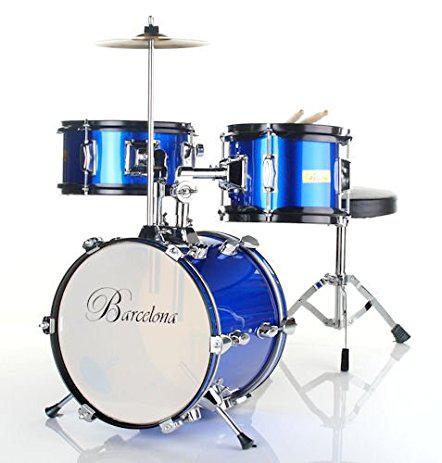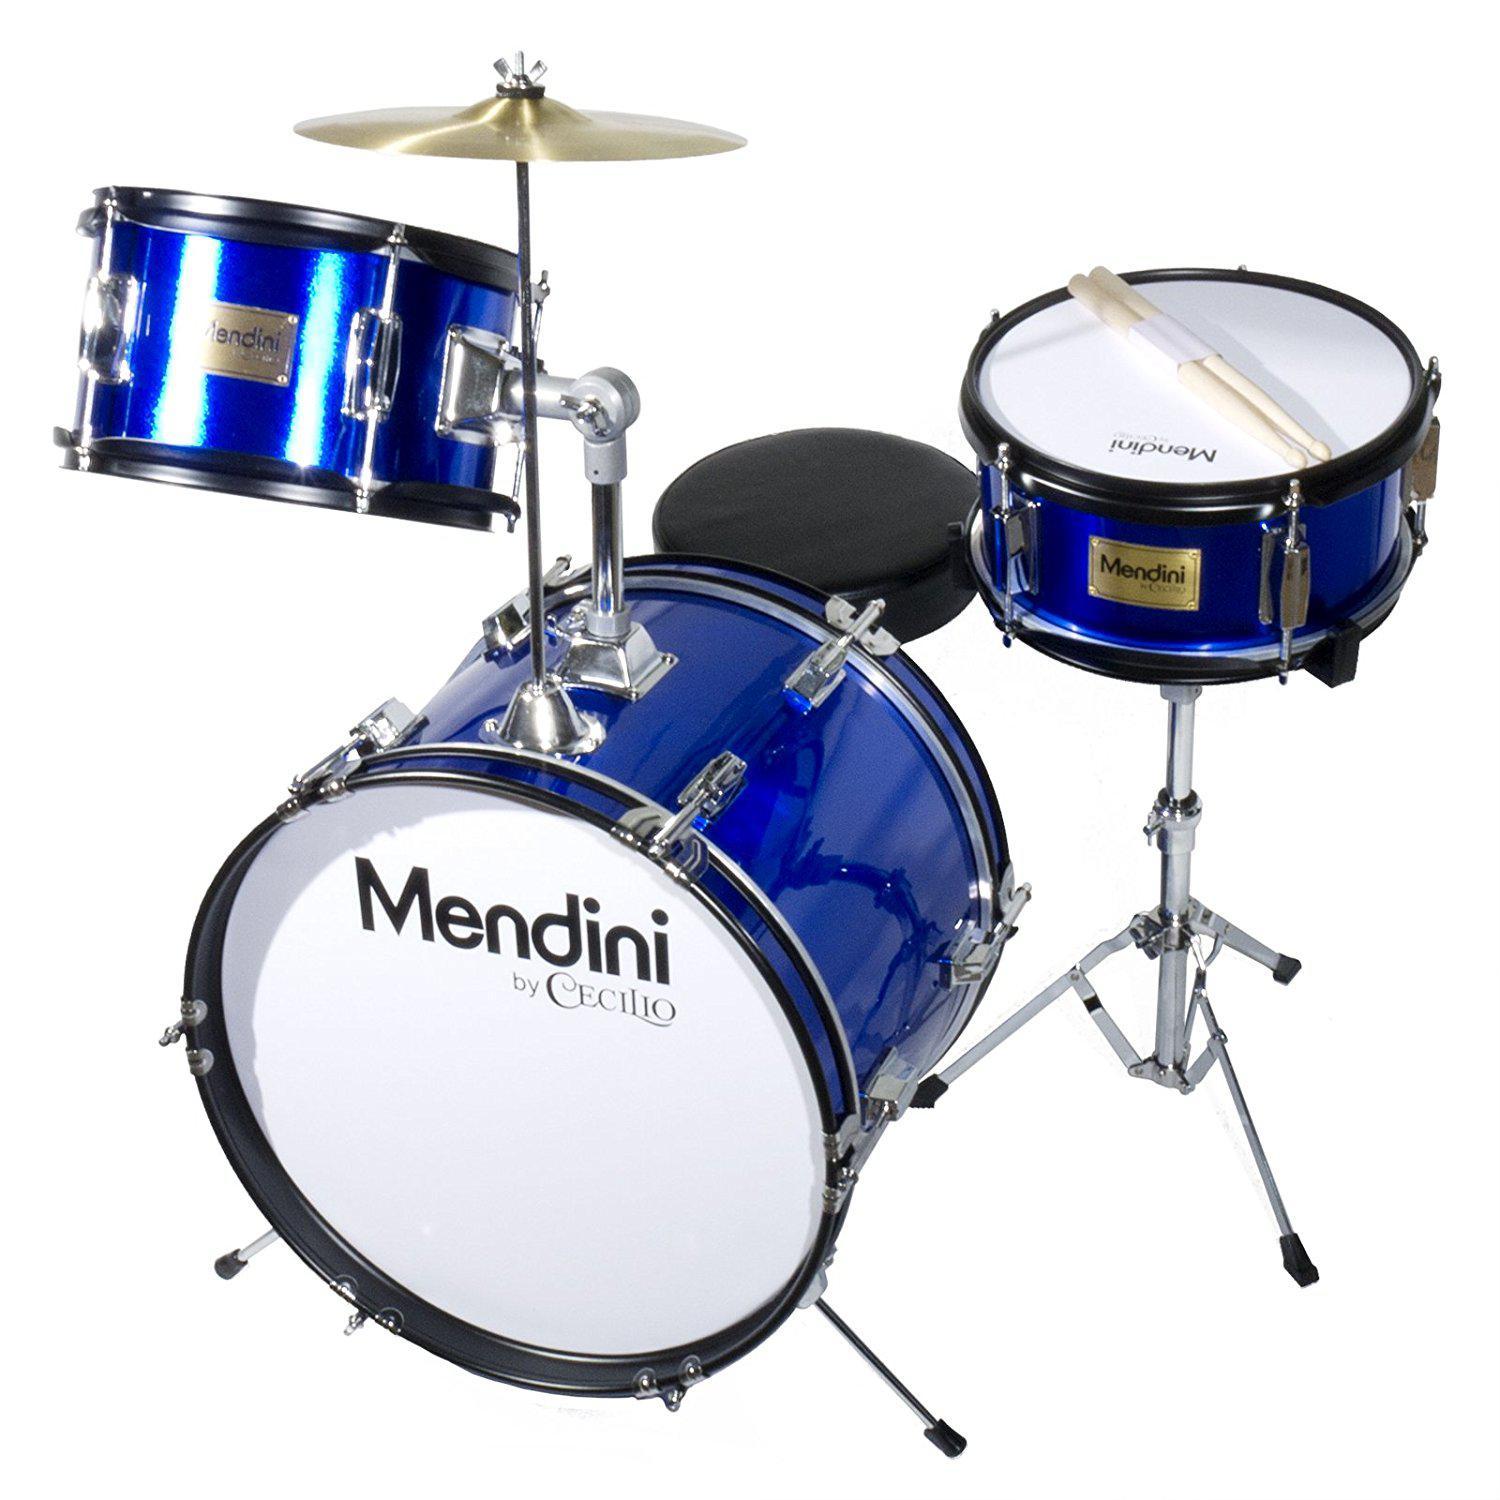The first image is the image on the left, the second image is the image on the right. Given the left and right images, does the statement "Eight or more drums are visible." hold true? Answer yes or no. No. 